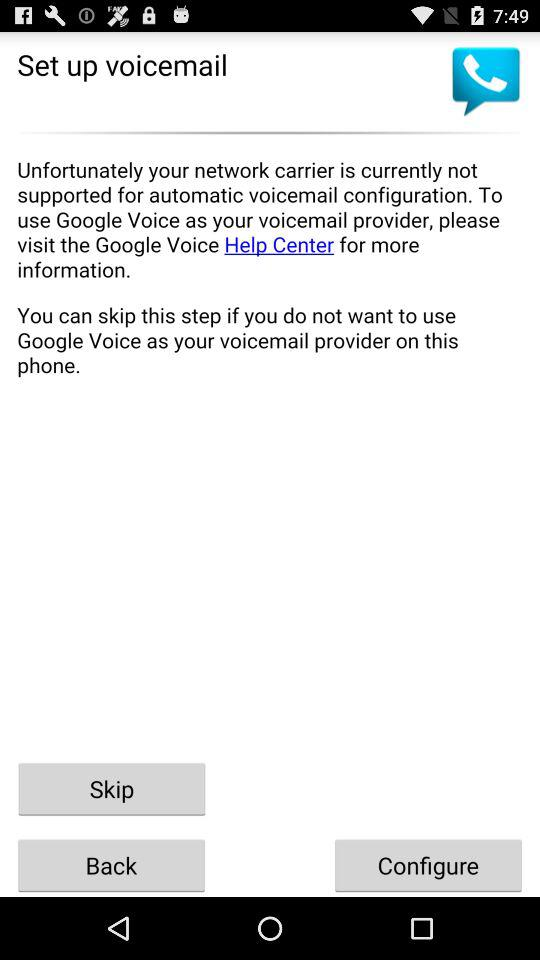What is the name of the application?
When the provided information is insufficient, respond with <no answer>. <no answer> 